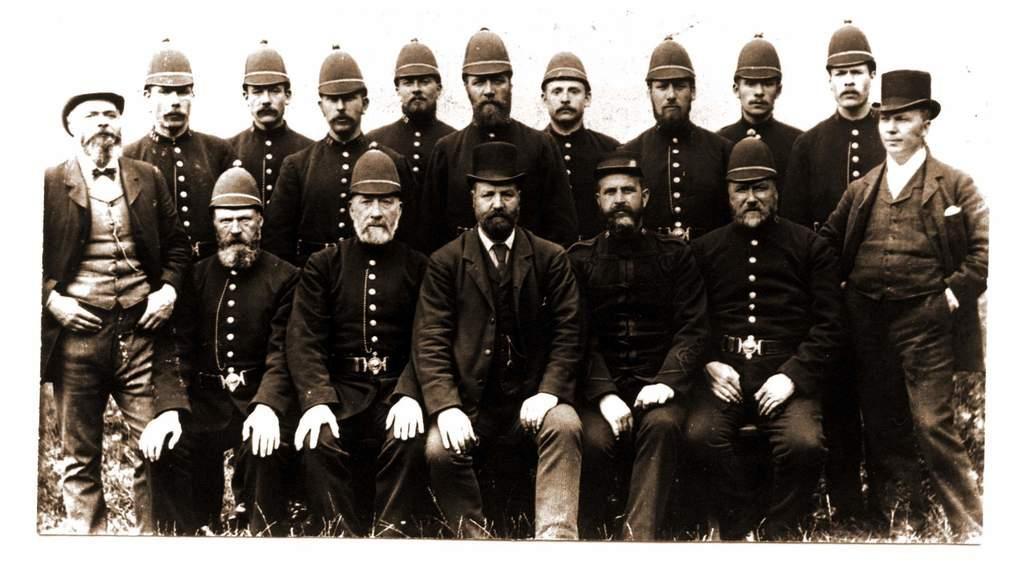Describe this image in one or two sentences. In this image I can see a few people sitting and other people standing. They are wearing caps and uniforms. This is a black and white image. 